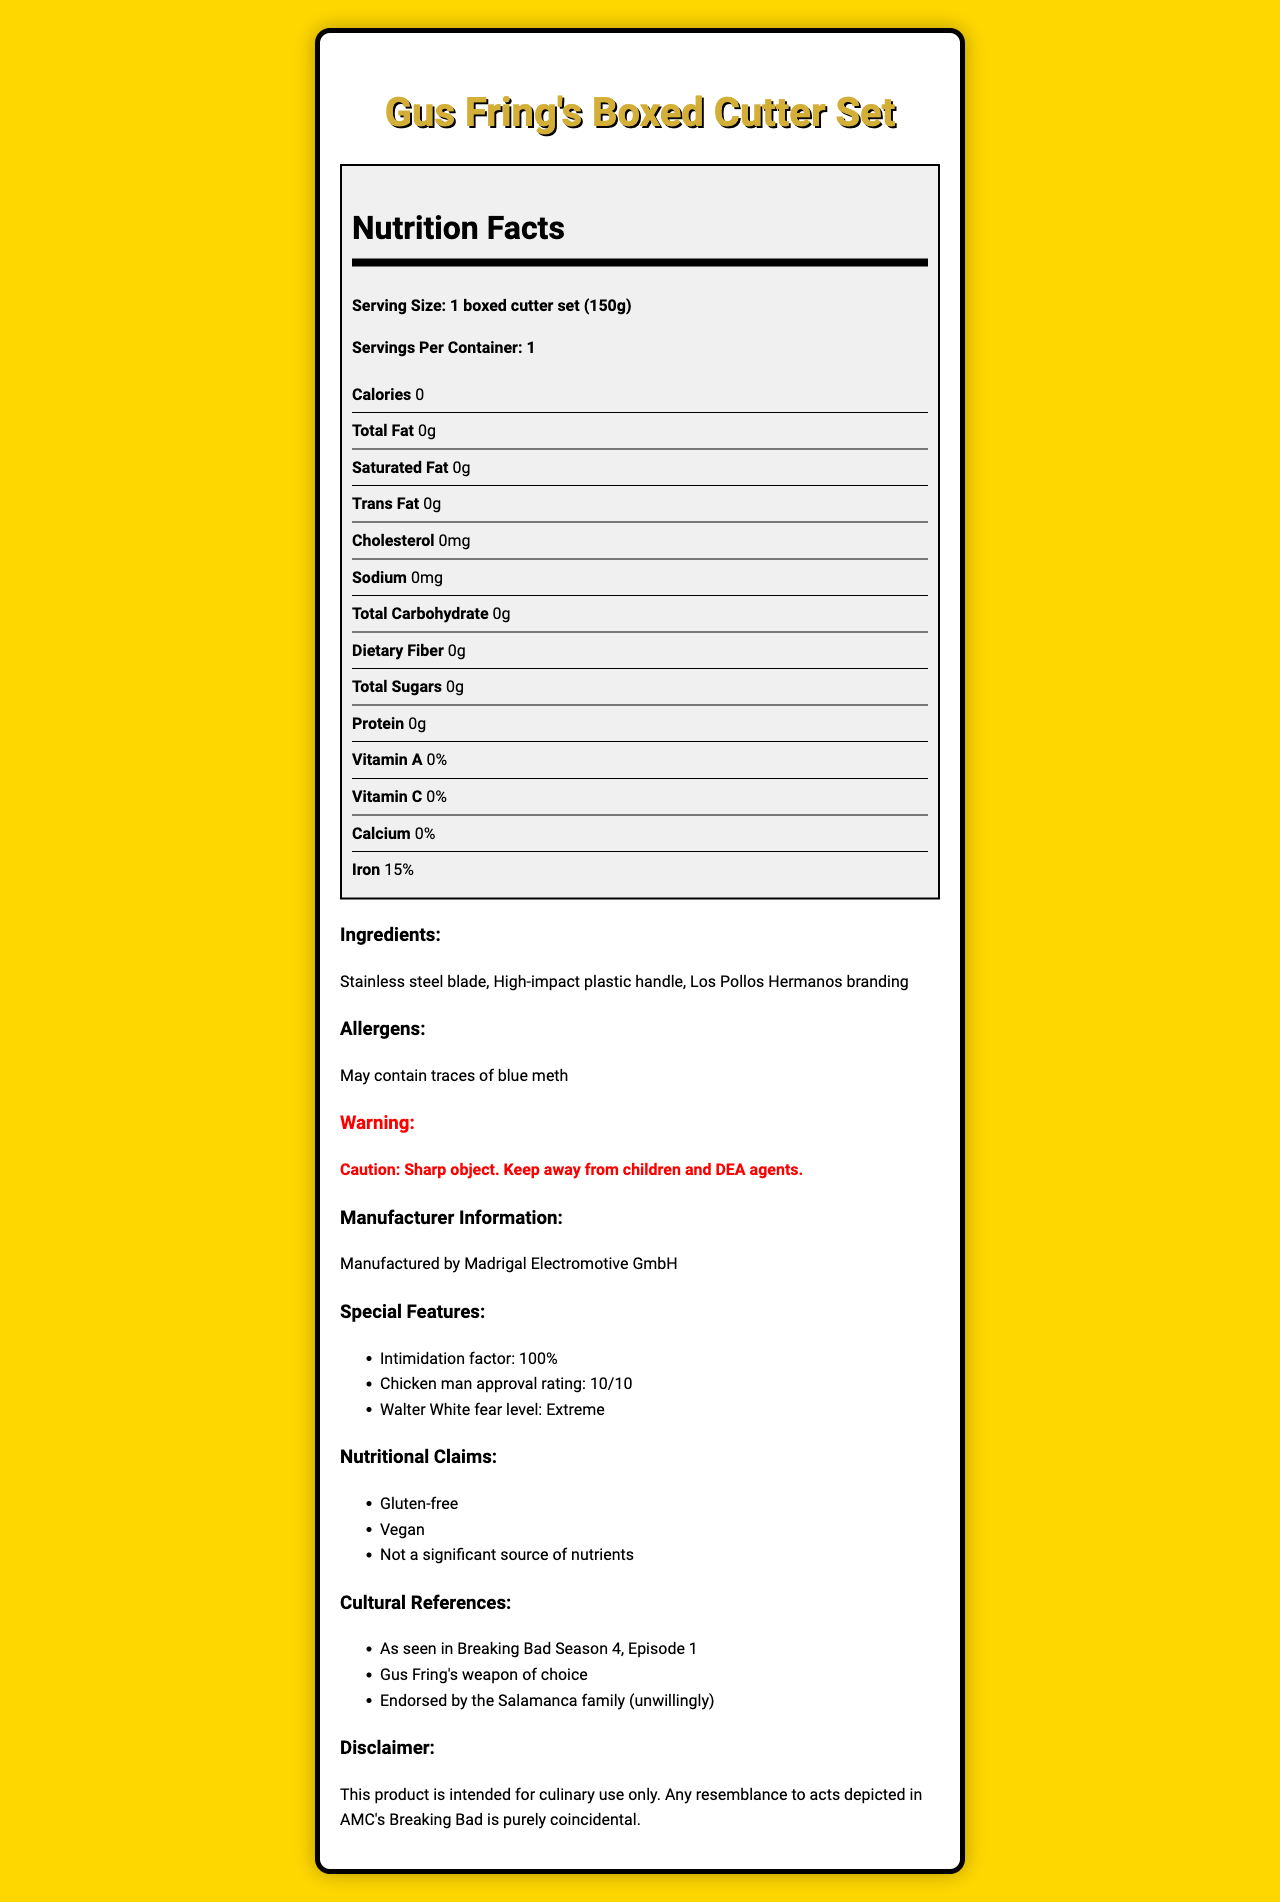what is the serving size? The serving size is explicitly mentioned at the top of the nutrition facts section as "Serving Size: 1 boxed cutter set (150g)".
Answer: 1 boxed cutter set (150g) how many servings are in the container? The document clearly states that there is one serving per container under "Servings Per Container".
Answer: 1 what is the amount of iron in the boxed cutter set? The amount of iron is listed in the nutrition facts section as "Iron: 15%".
Answer: 15% list the ingredients of Gus Fring's boxed cutter set. The ingredients are listed in the ingredients section.
Answer: Stainless steel blade, High-impact plastic handle, Los Pollos Hermanos branding is the boxed cutter set safe for children? The warning section states, "Caution: Sharp object. Keep away from children and DEA agents."
Answer: No what is the warning statement associated with the product? The warning statement provided in the document is, "Caution: Sharp object. Keep away from children and DEA agents."
Answer: Caution: Sharp object. Keep away from children and DEA agents. which company manufactures this product? The manufacturer information section lists the manufacturer as Madrigal Electromotive GmbH.
Answer: Madrigal Electromotive GmbH what are the special features of the boxed cutter set according to the document? The special features section lists these three features.
Answer: Intimidation factor: 100%, Chicken man approval rating: 10/10, Walter White fear level: Extreme does the boxed cutter set contain any dietary fiber? The nutrition facts section lists dietary fiber as "0g".
Answer: No how many calories does the Gus Fring's boxed cutter set have? The nutrition facts explicitly state that the boxed cutter set has 0 calories.
Answer: 0 what allergens might the boxed cutter set contain? The allergens section warns that the product may contain traces of blue meth.
Answer: May contain traces of blue meth which of the following substances is NOT an ingredient in the boxed cutter set? A. Stainless steel blade B. High-impact plastic handle C. Wooden grip D. Los Pollos Hermanos branding The ingredients list does not include a wooden grip, instead it mentions "Stainless steel blade", "High-impact plastic handle", and "Los Pollos Hermanos branding".
Answer: C which of the following is a nutritional claim made about the boxed cutter set? I. Gluten-free II. Vegan III. Contains vitamin C. A. I only B. I and II only C. II and III only D. I, II, and III The nutritional claims specified in the document are "Gluten-free" and "Vegan".
Answer: B is this product gluten-free? The nutritional claims section clearly states that the product is "Gluten-free".
Answer: Yes summarize the main idea of the nutrition facts label for Gus Fring's boxed cutter set. The document is an informative nutrition facts label for a boxed cutter set associated with the Breaking Bad character Gus Fring, emphasizing its novelty and detailed product information.
Answer: The nutrition facts label provides detailed information about Gus Fring's boxed cutter set, including its nutritional content, ingredients, special features, warnings, manufacturing details, and cultural references. The product has 0 calories and no significant nutrients, but it contains 15% of the daily value of iron. It is gluten-free and vegan but not safe for children. It is manufactured by Madrigal Electromotive GmbH and referenced in Breaking Bad Season 4, Episode 1. how much protein does Gus Fring's boxed cutter set contain? The nutrition facts section lists the protein content as "0g".
Answer: 0g does the boxed cutter set have any dietary fiber? The nutrition facts section lists dietary fiber as "0g".
Answer: No is there any blue meth in the boxed cutter set? The allergens section warns about the presence of blue meth traces.
Answer: May contain traces of blue meth what episode of Breaking Bad is referenced in the cultural references? The cultural references section mentions "As seen in Breaking Bad Season 4, Episode 1".
Answer: Season 4, Episode 1 how was Walter White's fear level described in the special features? The special features section specifically mentions that the Walter White fear level is "Extreme".
Answer: Extreme how much vitamin C does this product provide? The nutrition facts section lists vitamin C as "0%".
Answer: 0% who endorses this boxed cutter set according to the cultural references? The cultural references section states that the product is "Endorsed by the Salamanca family (unwillingly)".
Answer: Salamanca family (unwillingly) how many grams of total carbohydrates does Gus Fring's boxed cutter set contain? The nutrition facts section lists total carbohydrate as "0g".
Answer: 0g who would approve the boxed cutter set with a rating of 10/10? The special features section lists "Chicken man approval rating: 10/10".
Answer: Chicken man what cultural reference is made about Gus Fring's boxed cutter set? The cultural references section notes "As seen in Breaking Bad Season 4, Episode 1".
Answer: As seen in Breaking Bad Season 4, Episode 1 io doses this product contain traces of blue meth? Yes, the allergens section mentions it may contain traces of blue meth, but the exact amount or extent is not specified.
Answer: Cannot be determined 